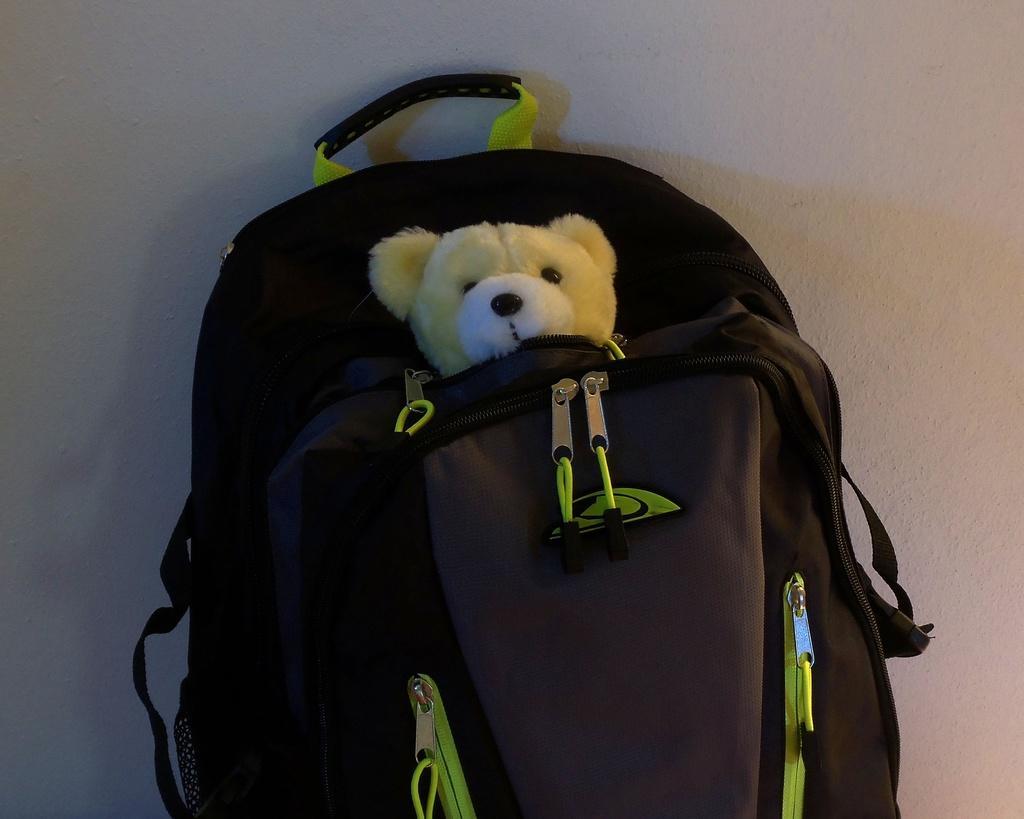Please provide a concise description of this image. There is a back with a teddy inside the back partially visible. 